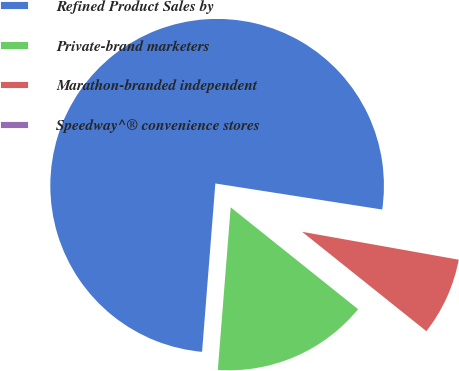Convert chart. <chart><loc_0><loc_0><loc_500><loc_500><pie_chart><fcel>Refined Product Sales by<fcel>Private-brand marketers<fcel>Marathon-branded independent<fcel>Speedway^® convenience stores<nl><fcel>76.22%<fcel>15.52%<fcel>7.93%<fcel>0.34%<nl></chart> 